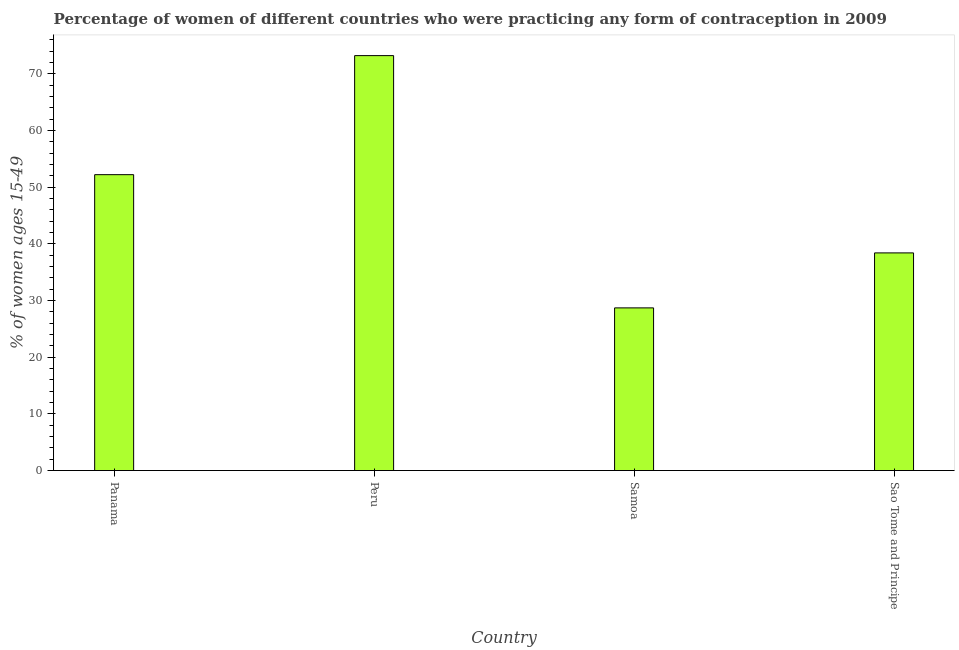Does the graph contain grids?
Give a very brief answer. No. What is the title of the graph?
Provide a short and direct response. Percentage of women of different countries who were practicing any form of contraception in 2009. What is the label or title of the Y-axis?
Offer a very short reply. % of women ages 15-49. What is the contraceptive prevalence in Panama?
Make the answer very short. 52.2. Across all countries, what is the maximum contraceptive prevalence?
Make the answer very short. 73.2. Across all countries, what is the minimum contraceptive prevalence?
Give a very brief answer. 28.7. In which country was the contraceptive prevalence minimum?
Provide a succinct answer. Samoa. What is the sum of the contraceptive prevalence?
Make the answer very short. 192.5. What is the difference between the contraceptive prevalence in Peru and Samoa?
Your response must be concise. 44.5. What is the average contraceptive prevalence per country?
Keep it short and to the point. 48.12. What is the median contraceptive prevalence?
Keep it short and to the point. 45.3. In how many countries, is the contraceptive prevalence greater than 44 %?
Offer a very short reply. 2. What is the ratio of the contraceptive prevalence in Panama to that in Peru?
Keep it short and to the point. 0.71. Is the contraceptive prevalence in Panama less than that in Peru?
Give a very brief answer. Yes. What is the difference between the highest and the lowest contraceptive prevalence?
Offer a very short reply. 44.5. In how many countries, is the contraceptive prevalence greater than the average contraceptive prevalence taken over all countries?
Offer a terse response. 2. Are all the bars in the graph horizontal?
Provide a short and direct response. No. What is the difference between two consecutive major ticks on the Y-axis?
Keep it short and to the point. 10. What is the % of women ages 15-49 in Panama?
Provide a short and direct response. 52.2. What is the % of women ages 15-49 in Peru?
Your answer should be very brief. 73.2. What is the % of women ages 15-49 in Samoa?
Your answer should be very brief. 28.7. What is the % of women ages 15-49 of Sao Tome and Principe?
Provide a succinct answer. 38.4. What is the difference between the % of women ages 15-49 in Panama and Peru?
Provide a short and direct response. -21. What is the difference between the % of women ages 15-49 in Panama and Samoa?
Offer a terse response. 23.5. What is the difference between the % of women ages 15-49 in Peru and Samoa?
Provide a short and direct response. 44.5. What is the difference between the % of women ages 15-49 in Peru and Sao Tome and Principe?
Your answer should be very brief. 34.8. What is the difference between the % of women ages 15-49 in Samoa and Sao Tome and Principe?
Make the answer very short. -9.7. What is the ratio of the % of women ages 15-49 in Panama to that in Peru?
Your answer should be compact. 0.71. What is the ratio of the % of women ages 15-49 in Panama to that in Samoa?
Provide a short and direct response. 1.82. What is the ratio of the % of women ages 15-49 in Panama to that in Sao Tome and Principe?
Make the answer very short. 1.36. What is the ratio of the % of women ages 15-49 in Peru to that in Samoa?
Your response must be concise. 2.55. What is the ratio of the % of women ages 15-49 in Peru to that in Sao Tome and Principe?
Your answer should be compact. 1.91. What is the ratio of the % of women ages 15-49 in Samoa to that in Sao Tome and Principe?
Keep it short and to the point. 0.75. 